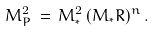<formula> <loc_0><loc_0><loc_500><loc_500>M _ { P } ^ { 2 } \, = \, M ^ { 2 } _ { * } \, ( M _ { * } R ) ^ { n } \, .</formula> 